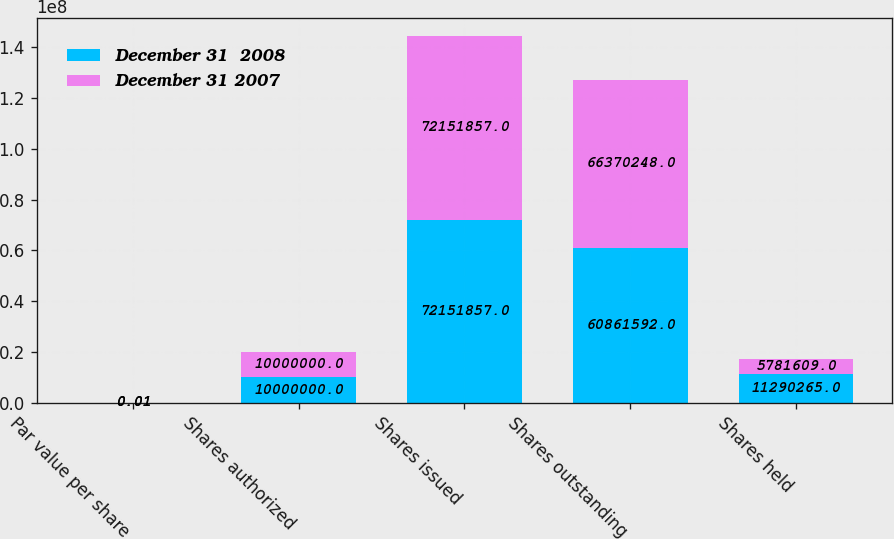<chart> <loc_0><loc_0><loc_500><loc_500><stacked_bar_chart><ecel><fcel>Par value per share<fcel>Shares authorized<fcel>Shares issued<fcel>Shares outstanding<fcel>Shares held<nl><fcel>December 31  2008<fcel>0.01<fcel>1e+07<fcel>7.21519e+07<fcel>6.08616e+07<fcel>1.12903e+07<nl><fcel>December 31 2007<fcel>0.01<fcel>1e+07<fcel>7.21519e+07<fcel>6.63702e+07<fcel>5.78161e+06<nl></chart> 